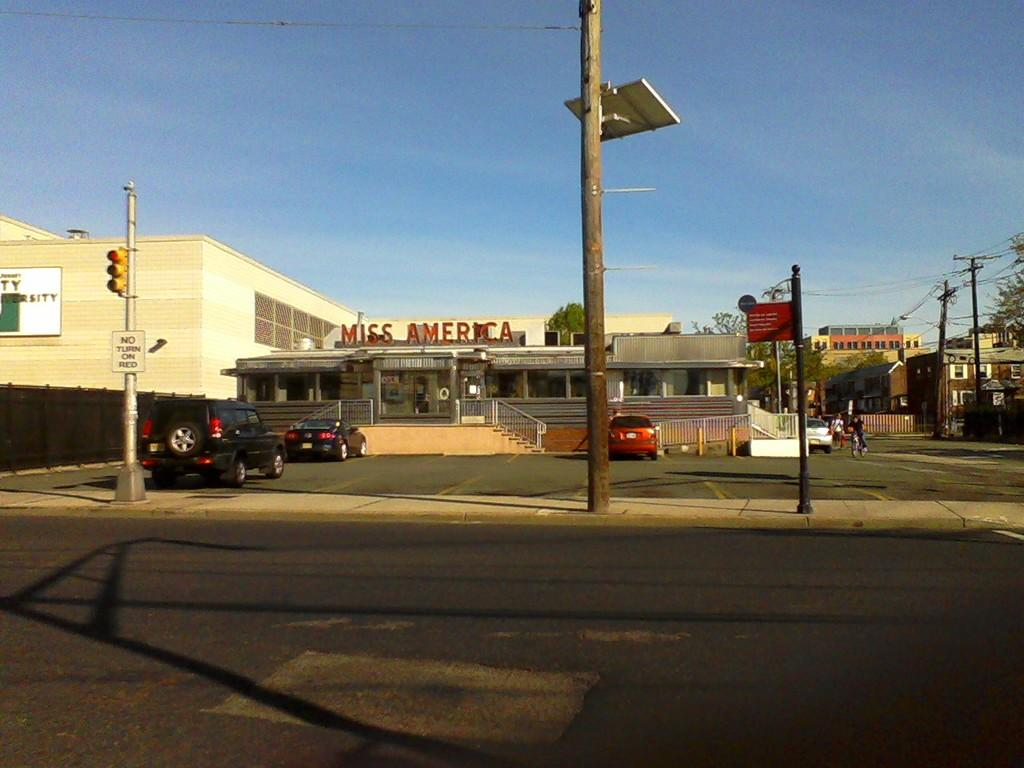What is attached to the poles in the image? There are boards attached to poles in the image. What can be used for climbing or descending in the image? There are stairs in the image. What type of structure is visible in the image? There is a building in the image. What is used for identifying locations or names in the image? There are name boards in the image. What are the people in the image doing? People are walking in the image. What is used for enclosing or separating areas in the image? There is a fence in the image. What is used for transmitting electricity in the image? There are current poles and wires visible in the image. What type of vegetation is present in the image? Trees are present in the image. What is the color of the sky in the background of the image? The sky in the background is blue. What type of trucks can be seen driving on the roads in the image? There are no roads or trucks visible in the image. What is the answer to the question "What is the capital of France?" in the image? The image does not contain any information about the capital of France, so it cannot provide an answer to that question. 